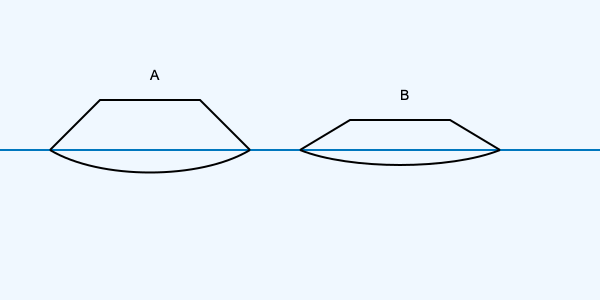Identify which of the simplified boat outlines (A or B) represents a typical Alaskan salmon gillnetter, a vessel commonly used in Bristol Bay and known for its distinctive shape? To identify the Alaskan salmon gillnetter, we need to consider the following characteristics:

1. Hull shape: Gillnetters typically have a wider, flatter hull to provide stability and deck space for handling nets.
2. Cabin position: The cabin is usually positioned towards the bow (front) of the vessel.
3. Stern (rear) design: Gillnetters often have a square or slightly rounded stern to accommodate net-handling equipment.

Analyzing the outlines:

A. This vessel has a wider hull with a flatter bottom, a cabin positioned towards the front, and a square stern. These features are consistent with a typical Alaskan salmon gillnetter.

B. This vessel has a narrower hull with a more pronounced V-shape, suggesting it's designed for speed rather than stability. The cabin appears to be more centrally located, and the stern is more pointed. These characteristics are more indicative of a different type of fishing vessel, possibly a seiner or a small troller.

Based on these observations, the outline that best represents a typical Alaskan salmon gillnetter is A.
Answer: A 